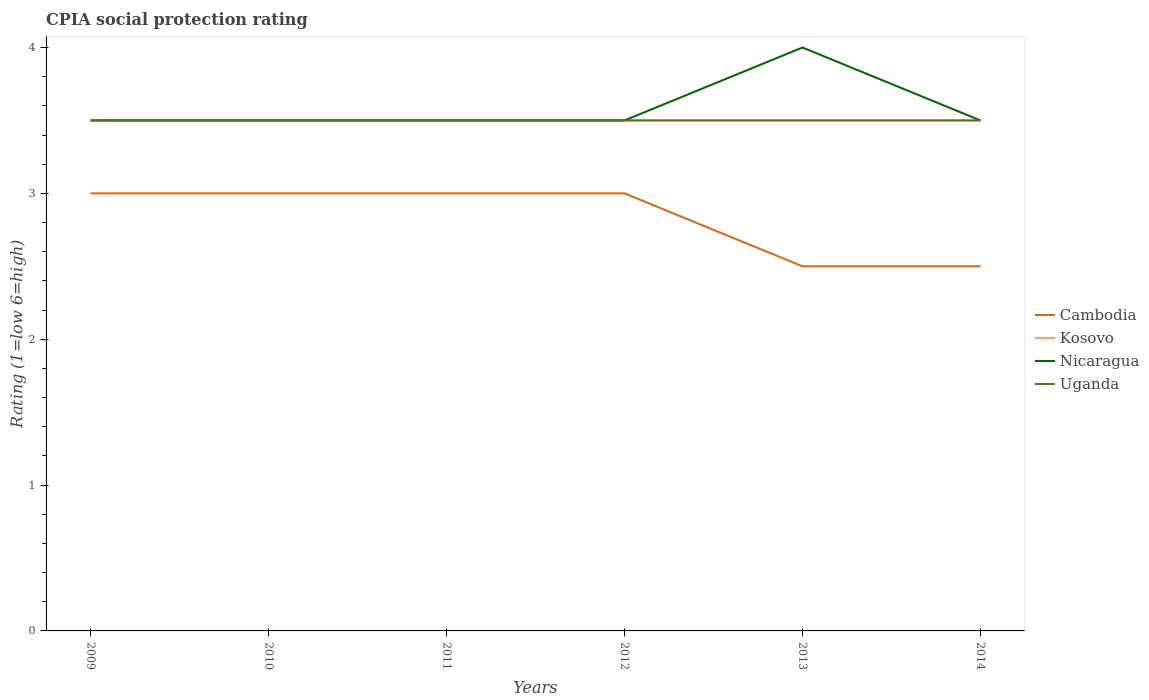Does the line corresponding to Kosovo intersect with the line corresponding to Uganda?
Your answer should be very brief. Yes. Is the number of lines equal to the number of legend labels?
Your response must be concise. Yes. In which year was the CPIA rating in Nicaragua maximum?
Keep it short and to the point. 2009. What is the total CPIA rating in Cambodia in the graph?
Give a very brief answer. 0.5. Is the CPIA rating in Nicaragua strictly greater than the CPIA rating in Kosovo over the years?
Offer a very short reply. No. How many years are there in the graph?
Your answer should be compact. 6. What is the difference between two consecutive major ticks on the Y-axis?
Provide a short and direct response. 1. Are the values on the major ticks of Y-axis written in scientific E-notation?
Your answer should be compact. No. Does the graph contain any zero values?
Give a very brief answer. No. How are the legend labels stacked?
Make the answer very short. Vertical. What is the title of the graph?
Your answer should be very brief. CPIA social protection rating. What is the label or title of the X-axis?
Your response must be concise. Years. What is the label or title of the Y-axis?
Provide a short and direct response. Rating (1=low 6=high). What is the Rating (1=low 6=high) in Cambodia in 2009?
Provide a short and direct response. 3. What is the Rating (1=low 6=high) of Kosovo in 2009?
Ensure brevity in your answer.  3.5. What is the Rating (1=low 6=high) in Cambodia in 2010?
Provide a short and direct response. 3. What is the Rating (1=low 6=high) of Cambodia in 2011?
Make the answer very short. 3. What is the Rating (1=low 6=high) of Kosovo in 2011?
Offer a very short reply. 3.5. What is the Rating (1=low 6=high) of Nicaragua in 2011?
Your answer should be compact. 3.5. What is the Rating (1=low 6=high) of Uganda in 2012?
Provide a succinct answer. 3.5. What is the Rating (1=low 6=high) of Cambodia in 2013?
Your response must be concise. 2.5. What is the Rating (1=low 6=high) in Uganda in 2013?
Keep it short and to the point. 3.5. What is the Rating (1=low 6=high) in Cambodia in 2014?
Provide a succinct answer. 2.5. What is the Rating (1=low 6=high) of Nicaragua in 2014?
Ensure brevity in your answer.  3.5. What is the Rating (1=low 6=high) of Uganda in 2014?
Your response must be concise. 3.5. Across all years, what is the maximum Rating (1=low 6=high) of Cambodia?
Provide a short and direct response. 3. Across all years, what is the minimum Rating (1=low 6=high) in Cambodia?
Your answer should be compact. 2.5. Across all years, what is the minimum Rating (1=low 6=high) in Kosovo?
Your response must be concise. 3.5. Across all years, what is the minimum Rating (1=low 6=high) in Nicaragua?
Your response must be concise. 3.5. Across all years, what is the minimum Rating (1=low 6=high) of Uganda?
Make the answer very short. 3.5. What is the total Rating (1=low 6=high) of Cambodia in the graph?
Your answer should be very brief. 17. What is the total Rating (1=low 6=high) of Kosovo in the graph?
Offer a very short reply. 21. What is the total Rating (1=low 6=high) in Uganda in the graph?
Offer a terse response. 21. What is the difference between the Rating (1=low 6=high) in Kosovo in 2009 and that in 2011?
Provide a short and direct response. 0. What is the difference between the Rating (1=low 6=high) in Cambodia in 2009 and that in 2012?
Give a very brief answer. 0. What is the difference between the Rating (1=low 6=high) in Kosovo in 2009 and that in 2012?
Make the answer very short. 0. What is the difference between the Rating (1=low 6=high) of Nicaragua in 2009 and that in 2012?
Keep it short and to the point. 0. What is the difference between the Rating (1=low 6=high) in Uganda in 2009 and that in 2012?
Keep it short and to the point. 0. What is the difference between the Rating (1=low 6=high) in Cambodia in 2009 and that in 2013?
Offer a very short reply. 0.5. What is the difference between the Rating (1=low 6=high) in Kosovo in 2009 and that in 2013?
Ensure brevity in your answer.  0. What is the difference between the Rating (1=low 6=high) of Nicaragua in 2009 and that in 2013?
Offer a very short reply. -0.5. What is the difference between the Rating (1=low 6=high) of Uganda in 2009 and that in 2014?
Ensure brevity in your answer.  0. What is the difference between the Rating (1=low 6=high) of Nicaragua in 2010 and that in 2011?
Offer a terse response. 0. What is the difference between the Rating (1=low 6=high) of Kosovo in 2010 and that in 2012?
Provide a succinct answer. 0. What is the difference between the Rating (1=low 6=high) of Nicaragua in 2010 and that in 2012?
Your answer should be compact. 0. What is the difference between the Rating (1=low 6=high) in Nicaragua in 2010 and that in 2013?
Provide a succinct answer. -0.5. What is the difference between the Rating (1=low 6=high) of Cambodia in 2010 and that in 2014?
Your answer should be very brief. 0.5. What is the difference between the Rating (1=low 6=high) of Nicaragua in 2010 and that in 2014?
Your response must be concise. 0. What is the difference between the Rating (1=low 6=high) in Uganda in 2010 and that in 2014?
Provide a succinct answer. 0. What is the difference between the Rating (1=low 6=high) in Cambodia in 2011 and that in 2012?
Provide a short and direct response. 0. What is the difference between the Rating (1=low 6=high) in Cambodia in 2011 and that in 2013?
Give a very brief answer. 0.5. What is the difference between the Rating (1=low 6=high) of Nicaragua in 2011 and that in 2013?
Your answer should be very brief. -0.5. What is the difference between the Rating (1=low 6=high) in Uganda in 2011 and that in 2013?
Make the answer very short. 0. What is the difference between the Rating (1=low 6=high) in Kosovo in 2011 and that in 2014?
Your answer should be compact. 0. What is the difference between the Rating (1=low 6=high) of Kosovo in 2012 and that in 2013?
Provide a succinct answer. 0. What is the difference between the Rating (1=low 6=high) of Nicaragua in 2012 and that in 2013?
Provide a short and direct response. -0.5. What is the difference between the Rating (1=low 6=high) of Uganda in 2012 and that in 2013?
Your response must be concise. 0. What is the difference between the Rating (1=low 6=high) of Kosovo in 2012 and that in 2014?
Provide a short and direct response. 0. What is the difference between the Rating (1=low 6=high) of Nicaragua in 2012 and that in 2014?
Offer a terse response. 0. What is the difference between the Rating (1=low 6=high) in Nicaragua in 2013 and that in 2014?
Provide a short and direct response. 0.5. What is the difference between the Rating (1=low 6=high) in Cambodia in 2009 and the Rating (1=low 6=high) in Kosovo in 2010?
Make the answer very short. -0.5. What is the difference between the Rating (1=low 6=high) in Cambodia in 2009 and the Rating (1=low 6=high) in Uganda in 2010?
Provide a succinct answer. -0.5. What is the difference between the Rating (1=low 6=high) in Kosovo in 2009 and the Rating (1=low 6=high) in Uganda in 2010?
Offer a terse response. 0. What is the difference between the Rating (1=low 6=high) of Nicaragua in 2009 and the Rating (1=low 6=high) of Uganda in 2010?
Offer a terse response. 0. What is the difference between the Rating (1=low 6=high) in Cambodia in 2009 and the Rating (1=low 6=high) in Kosovo in 2011?
Your response must be concise. -0.5. What is the difference between the Rating (1=low 6=high) of Cambodia in 2009 and the Rating (1=low 6=high) of Uganda in 2012?
Ensure brevity in your answer.  -0.5. What is the difference between the Rating (1=low 6=high) of Kosovo in 2009 and the Rating (1=low 6=high) of Nicaragua in 2012?
Keep it short and to the point. 0. What is the difference between the Rating (1=low 6=high) of Kosovo in 2009 and the Rating (1=low 6=high) of Uganda in 2012?
Provide a succinct answer. 0. What is the difference between the Rating (1=low 6=high) of Nicaragua in 2009 and the Rating (1=low 6=high) of Uganda in 2012?
Provide a short and direct response. 0. What is the difference between the Rating (1=low 6=high) of Kosovo in 2009 and the Rating (1=low 6=high) of Nicaragua in 2013?
Your answer should be very brief. -0.5. What is the difference between the Rating (1=low 6=high) in Cambodia in 2009 and the Rating (1=low 6=high) in Kosovo in 2014?
Ensure brevity in your answer.  -0.5. What is the difference between the Rating (1=low 6=high) in Cambodia in 2009 and the Rating (1=low 6=high) in Nicaragua in 2014?
Give a very brief answer. -0.5. What is the difference between the Rating (1=low 6=high) of Cambodia in 2009 and the Rating (1=low 6=high) of Uganda in 2014?
Your answer should be compact. -0.5. What is the difference between the Rating (1=low 6=high) of Kosovo in 2009 and the Rating (1=low 6=high) of Nicaragua in 2014?
Your answer should be compact. 0. What is the difference between the Rating (1=low 6=high) of Cambodia in 2010 and the Rating (1=low 6=high) of Kosovo in 2011?
Provide a short and direct response. -0.5. What is the difference between the Rating (1=low 6=high) in Cambodia in 2010 and the Rating (1=low 6=high) in Nicaragua in 2011?
Provide a succinct answer. -0.5. What is the difference between the Rating (1=low 6=high) of Kosovo in 2010 and the Rating (1=low 6=high) of Uganda in 2011?
Your response must be concise. 0. What is the difference between the Rating (1=low 6=high) in Nicaragua in 2010 and the Rating (1=low 6=high) in Uganda in 2011?
Your response must be concise. 0. What is the difference between the Rating (1=low 6=high) of Cambodia in 2010 and the Rating (1=low 6=high) of Kosovo in 2012?
Offer a terse response. -0.5. What is the difference between the Rating (1=low 6=high) in Kosovo in 2010 and the Rating (1=low 6=high) in Nicaragua in 2013?
Your response must be concise. -0.5. What is the difference between the Rating (1=low 6=high) of Cambodia in 2010 and the Rating (1=low 6=high) of Kosovo in 2014?
Ensure brevity in your answer.  -0.5. What is the difference between the Rating (1=low 6=high) in Cambodia in 2010 and the Rating (1=low 6=high) in Nicaragua in 2014?
Your answer should be very brief. -0.5. What is the difference between the Rating (1=low 6=high) of Kosovo in 2010 and the Rating (1=low 6=high) of Uganda in 2014?
Ensure brevity in your answer.  0. What is the difference between the Rating (1=low 6=high) in Cambodia in 2011 and the Rating (1=low 6=high) in Uganda in 2012?
Your response must be concise. -0.5. What is the difference between the Rating (1=low 6=high) in Kosovo in 2011 and the Rating (1=low 6=high) in Uganda in 2012?
Make the answer very short. 0. What is the difference between the Rating (1=low 6=high) in Nicaragua in 2011 and the Rating (1=low 6=high) in Uganda in 2012?
Keep it short and to the point. 0. What is the difference between the Rating (1=low 6=high) in Cambodia in 2011 and the Rating (1=low 6=high) in Nicaragua in 2013?
Your answer should be very brief. -1. What is the difference between the Rating (1=low 6=high) of Cambodia in 2011 and the Rating (1=low 6=high) of Uganda in 2013?
Keep it short and to the point. -0.5. What is the difference between the Rating (1=low 6=high) in Nicaragua in 2011 and the Rating (1=low 6=high) in Uganda in 2013?
Provide a succinct answer. 0. What is the difference between the Rating (1=low 6=high) in Kosovo in 2011 and the Rating (1=low 6=high) in Nicaragua in 2014?
Ensure brevity in your answer.  0. What is the difference between the Rating (1=low 6=high) in Nicaragua in 2011 and the Rating (1=low 6=high) in Uganda in 2014?
Give a very brief answer. 0. What is the difference between the Rating (1=low 6=high) of Cambodia in 2012 and the Rating (1=low 6=high) of Uganda in 2013?
Provide a short and direct response. -0.5. What is the difference between the Rating (1=low 6=high) in Kosovo in 2012 and the Rating (1=low 6=high) in Uganda in 2013?
Your answer should be compact. 0. What is the difference between the Rating (1=low 6=high) in Nicaragua in 2012 and the Rating (1=low 6=high) in Uganda in 2013?
Give a very brief answer. 0. What is the difference between the Rating (1=low 6=high) in Cambodia in 2012 and the Rating (1=low 6=high) in Nicaragua in 2014?
Keep it short and to the point. -0.5. What is the difference between the Rating (1=low 6=high) in Cambodia in 2012 and the Rating (1=low 6=high) in Uganda in 2014?
Make the answer very short. -0.5. What is the difference between the Rating (1=low 6=high) of Kosovo in 2012 and the Rating (1=low 6=high) of Uganda in 2014?
Offer a terse response. 0. What is the difference between the Rating (1=low 6=high) of Nicaragua in 2012 and the Rating (1=low 6=high) of Uganda in 2014?
Your answer should be very brief. 0. What is the difference between the Rating (1=low 6=high) of Cambodia in 2013 and the Rating (1=low 6=high) of Kosovo in 2014?
Keep it short and to the point. -1. What is the difference between the Rating (1=low 6=high) in Kosovo in 2013 and the Rating (1=low 6=high) in Nicaragua in 2014?
Provide a short and direct response. 0. What is the difference between the Rating (1=low 6=high) of Nicaragua in 2013 and the Rating (1=low 6=high) of Uganda in 2014?
Offer a very short reply. 0.5. What is the average Rating (1=low 6=high) of Cambodia per year?
Provide a succinct answer. 2.83. What is the average Rating (1=low 6=high) in Nicaragua per year?
Provide a succinct answer. 3.58. What is the average Rating (1=low 6=high) in Uganda per year?
Give a very brief answer. 3.5. In the year 2009, what is the difference between the Rating (1=low 6=high) in Kosovo and Rating (1=low 6=high) in Uganda?
Ensure brevity in your answer.  0. In the year 2009, what is the difference between the Rating (1=low 6=high) in Nicaragua and Rating (1=low 6=high) in Uganda?
Your answer should be compact. 0. In the year 2010, what is the difference between the Rating (1=low 6=high) of Cambodia and Rating (1=low 6=high) of Kosovo?
Give a very brief answer. -0.5. In the year 2010, what is the difference between the Rating (1=low 6=high) of Cambodia and Rating (1=low 6=high) of Nicaragua?
Offer a very short reply. -0.5. In the year 2010, what is the difference between the Rating (1=low 6=high) in Cambodia and Rating (1=low 6=high) in Uganda?
Ensure brevity in your answer.  -0.5. In the year 2010, what is the difference between the Rating (1=low 6=high) in Nicaragua and Rating (1=low 6=high) in Uganda?
Provide a short and direct response. 0. In the year 2011, what is the difference between the Rating (1=low 6=high) of Cambodia and Rating (1=low 6=high) of Kosovo?
Ensure brevity in your answer.  -0.5. In the year 2011, what is the difference between the Rating (1=low 6=high) of Cambodia and Rating (1=low 6=high) of Nicaragua?
Make the answer very short. -0.5. In the year 2011, what is the difference between the Rating (1=low 6=high) of Cambodia and Rating (1=low 6=high) of Uganda?
Provide a succinct answer. -0.5. In the year 2011, what is the difference between the Rating (1=low 6=high) in Kosovo and Rating (1=low 6=high) in Nicaragua?
Provide a succinct answer. 0. In the year 2012, what is the difference between the Rating (1=low 6=high) of Cambodia and Rating (1=low 6=high) of Kosovo?
Offer a terse response. -0.5. In the year 2012, what is the difference between the Rating (1=low 6=high) of Cambodia and Rating (1=low 6=high) of Nicaragua?
Offer a terse response. -0.5. In the year 2012, what is the difference between the Rating (1=low 6=high) in Kosovo and Rating (1=low 6=high) in Uganda?
Your answer should be compact. 0. In the year 2012, what is the difference between the Rating (1=low 6=high) in Nicaragua and Rating (1=low 6=high) in Uganda?
Offer a very short reply. 0. In the year 2013, what is the difference between the Rating (1=low 6=high) in Cambodia and Rating (1=low 6=high) in Kosovo?
Make the answer very short. -1. In the year 2013, what is the difference between the Rating (1=low 6=high) in Cambodia and Rating (1=low 6=high) in Uganda?
Your answer should be very brief. -1. In the year 2014, what is the difference between the Rating (1=low 6=high) of Cambodia and Rating (1=low 6=high) of Nicaragua?
Give a very brief answer. -1. In the year 2014, what is the difference between the Rating (1=low 6=high) of Kosovo and Rating (1=low 6=high) of Nicaragua?
Make the answer very short. 0. In the year 2014, what is the difference between the Rating (1=low 6=high) in Nicaragua and Rating (1=low 6=high) in Uganda?
Provide a succinct answer. 0. What is the ratio of the Rating (1=low 6=high) of Kosovo in 2009 to that in 2010?
Offer a terse response. 1. What is the ratio of the Rating (1=low 6=high) in Nicaragua in 2009 to that in 2011?
Make the answer very short. 1. What is the ratio of the Rating (1=low 6=high) in Uganda in 2009 to that in 2011?
Offer a terse response. 1. What is the ratio of the Rating (1=low 6=high) of Nicaragua in 2009 to that in 2012?
Give a very brief answer. 1. What is the ratio of the Rating (1=low 6=high) in Cambodia in 2009 to that in 2013?
Your response must be concise. 1.2. What is the ratio of the Rating (1=low 6=high) in Kosovo in 2009 to that in 2013?
Make the answer very short. 1. What is the ratio of the Rating (1=low 6=high) of Nicaragua in 2009 to that in 2013?
Provide a short and direct response. 0.88. What is the ratio of the Rating (1=low 6=high) in Cambodia in 2010 to that in 2011?
Give a very brief answer. 1. What is the ratio of the Rating (1=low 6=high) of Uganda in 2010 to that in 2011?
Offer a very short reply. 1. What is the ratio of the Rating (1=low 6=high) of Uganda in 2010 to that in 2012?
Offer a very short reply. 1. What is the ratio of the Rating (1=low 6=high) of Kosovo in 2010 to that in 2013?
Your answer should be compact. 1. What is the ratio of the Rating (1=low 6=high) in Cambodia in 2010 to that in 2014?
Provide a short and direct response. 1.2. What is the ratio of the Rating (1=low 6=high) of Cambodia in 2011 to that in 2012?
Your response must be concise. 1. What is the ratio of the Rating (1=low 6=high) in Nicaragua in 2011 to that in 2012?
Your response must be concise. 1. What is the ratio of the Rating (1=low 6=high) of Uganda in 2011 to that in 2012?
Offer a terse response. 1. What is the ratio of the Rating (1=low 6=high) of Cambodia in 2011 to that in 2013?
Provide a succinct answer. 1.2. What is the ratio of the Rating (1=low 6=high) in Kosovo in 2011 to that in 2013?
Your answer should be compact. 1. What is the ratio of the Rating (1=low 6=high) of Nicaragua in 2011 to that in 2013?
Offer a terse response. 0.88. What is the ratio of the Rating (1=low 6=high) of Cambodia in 2011 to that in 2014?
Your answer should be very brief. 1.2. What is the ratio of the Rating (1=low 6=high) in Kosovo in 2011 to that in 2014?
Offer a very short reply. 1. What is the ratio of the Rating (1=low 6=high) in Nicaragua in 2011 to that in 2014?
Offer a very short reply. 1. What is the ratio of the Rating (1=low 6=high) of Uganda in 2011 to that in 2014?
Give a very brief answer. 1. What is the ratio of the Rating (1=low 6=high) of Cambodia in 2012 to that in 2013?
Offer a very short reply. 1.2. What is the ratio of the Rating (1=low 6=high) in Kosovo in 2012 to that in 2013?
Your answer should be very brief. 1. What is the ratio of the Rating (1=low 6=high) of Nicaragua in 2012 to that in 2013?
Give a very brief answer. 0.88. What is the ratio of the Rating (1=low 6=high) in Uganda in 2012 to that in 2013?
Keep it short and to the point. 1. What is the ratio of the Rating (1=low 6=high) in Cambodia in 2012 to that in 2014?
Make the answer very short. 1.2. What is the ratio of the Rating (1=low 6=high) of Kosovo in 2012 to that in 2014?
Keep it short and to the point. 1. What is the ratio of the Rating (1=low 6=high) of Nicaragua in 2012 to that in 2014?
Make the answer very short. 1. What is the ratio of the Rating (1=low 6=high) of Uganda in 2012 to that in 2014?
Provide a succinct answer. 1. What is the difference between the highest and the second highest Rating (1=low 6=high) in Cambodia?
Ensure brevity in your answer.  0. What is the difference between the highest and the second highest Rating (1=low 6=high) in Kosovo?
Offer a terse response. 0. What is the difference between the highest and the second highest Rating (1=low 6=high) of Nicaragua?
Offer a terse response. 0.5. What is the difference between the highest and the second highest Rating (1=low 6=high) of Uganda?
Your answer should be very brief. 0. What is the difference between the highest and the lowest Rating (1=low 6=high) in Cambodia?
Your answer should be very brief. 0.5. What is the difference between the highest and the lowest Rating (1=low 6=high) of Kosovo?
Your answer should be very brief. 0. What is the difference between the highest and the lowest Rating (1=low 6=high) in Uganda?
Provide a succinct answer. 0. 